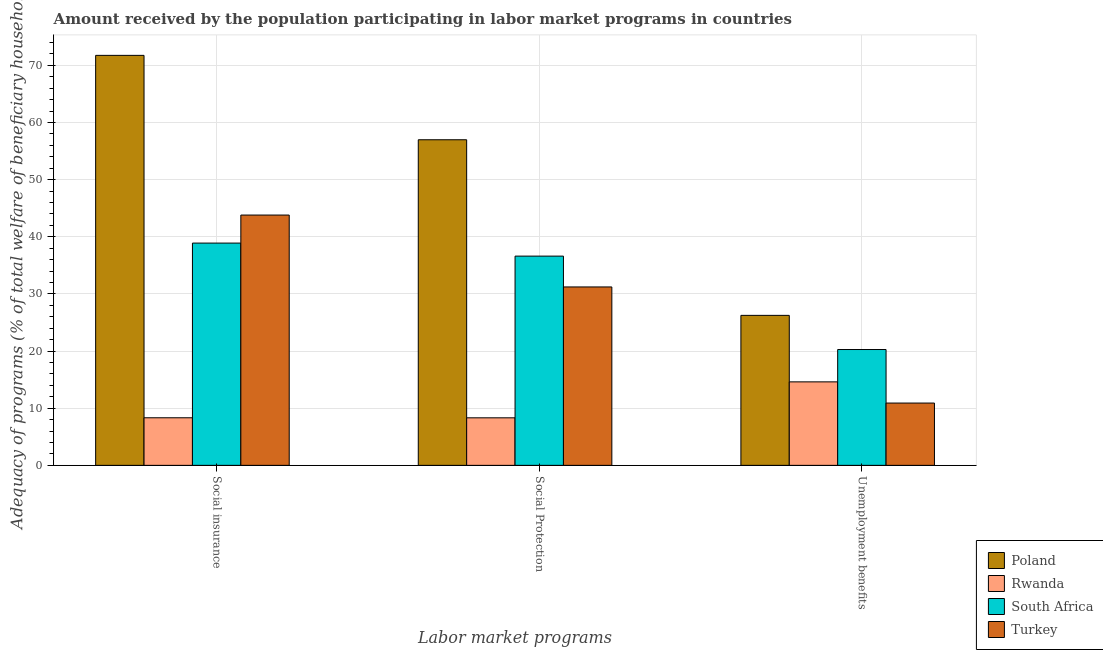How many groups of bars are there?
Your answer should be compact. 3. Are the number of bars per tick equal to the number of legend labels?
Give a very brief answer. Yes. Are the number of bars on each tick of the X-axis equal?
Offer a terse response. Yes. How many bars are there on the 2nd tick from the left?
Give a very brief answer. 4. How many bars are there on the 2nd tick from the right?
Your response must be concise. 4. What is the label of the 3rd group of bars from the left?
Make the answer very short. Unemployment benefits. What is the amount received by the population participating in social protection programs in Turkey?
Provide a succinct answer. 31.22. Across all countries, what is the maximum amount received by the population participating in unemployment benefits programs?
Provide a succinct answer. 26.25. Across all countries, what is the minimum amount received by the population participating in unemployment benefits programs?
Your answer should be compact. 10.9. What is the total amount received by the population participating in social protection programs in the graph?
Keep it short and to the point. 133.15. What is the difference between the amount received by the population participating in social protection programs in Turkey and that in Poland?
Provide a succinct answer. -25.76. What is the difference between the amount received by the population participating in unemployment benefits programs in Turkey and the amount received by the population participating in social protection programs in Poland?
Provide a succinct answer. -46.08. What is the average amount received by the population participating in unemployment benefits programs per country?
Your answer should be very brief. 18.01. What is the difference between the amount received by the population participating in social protection programs and amount received by the population participating in unemployment benefits programs in South Africa?
Offer a very short reply. 16.35. What is the ratio of the amount received by the population participating in social insurance programs in South Africa to that in Poland?
Give a very brief answer. 0.54. Is the amount received by the population participating in unemployment benefits programs in Rwanda less than that in Poland?
Provide a succinct answer. Yes. What is the difference between the highest and the second highest amount received by the population participating in unemployment benefits programs?
Your response must be concise. 5.98. What is the difference between the highest and the lowest amount received by the population participating in social protection programs?
Offer a very short reply. 48.67. Is the sum of the amount received by the population participating in social protection programs in Rwanda and Poland greater than the maximum amount received by the population participating in unemployment benefits programs across all countries?
Ensure brevity in your answer.  Yes. What does the 2nd bar from the left in Social Protection represents?
Offer a terse response. Rwanda. Are all the bars in the graph horizontal?
Provide a succinct answer. No. Does the graph contain any zero values?
Your answer should be compact. No. Where does the legend appear in the graph?
Offer a very short reply. Bottom right. What is the title of the graph?
Provide a succinct answer. Amount received by the population participating in labor market programs in countries. Does "Uganda" appear as one of the legend labels in the graph?
Give a very brief answer. No. What is the label or title of the X-axis?
Make the answer very short. Labor market programs. What is the label or title of the Y-axis?
Offer a terse response. Adequacy of programs (% of total welfare of beneficiary households). What is the Adequacy of programs (% of total welfare of beneficiary households) of Poland in Social insurance?
Give a very brief answer. 71.75. What is the Adequacy of programs (% of total welfare of beneficiary households) in Rwanda in Social insurance?
Your answer should be very brief. 8.33. What is the Adequacy of programs (% of total welfare of beneficiary households) in South Africa in Social insurance?
Make the answer very short. 38.9. What is the Adequacy of programs (% of total welfare of beneficiary households) in Turkey in Social insurance?
Give a very brief answer. 43.81. What is the Adequacy of programs (% of total welfare of beneficiary households) in Poland in Social Protection?
Your response must be concise. 56.99. What is the Adequacy of programs (% of total welfare of beneficiary households) in Rwanda in Social Protection?
Make the answer very short. 8.32. What is the Adequacy of programs (% of total welfare of beneficiary households) in South Africa in Social Protection?
Offer a terse response. 36.62. What is the Adequacy of programs (% of total welfare of beneficiary households) of Turkey in Social Protection?
Offer a very short reply. 31.22. What is the Adequacy of programs (% of total welfare of beneficiary households) in Poland in Unemployment benefits?
Provide a short and direct response. 26.25. What is the Adequacy of programs (% of total welfare of beneficiary households) in Rwanda in Unemployment benefits?
Provide a succinct answer. 14.61. What is the Adequacy of programs (% of total welfare of beneficiary households) of South Africa in Unemployment benefits?
Your response must be concise. 20.27. What is the Adequacy of programs (% of total welfare of beneficiary households) of Turkey in Unemployment benefits?
Make the answer very short. 10.9. Across all Labor market programs, what is the maximum Adequacy of programs (% of total welfare of beneficiary households) of Poland?
Offer a very short reply. 71.75. Across all Labor market programs, what is the maximum Adequacy of programs (% of total welfare of beneficiary households) in Rwanda?
Keep it short and to the point. 14.61. Across all Labor market programs, what is the maximum Adequacy of programs (% of total welfare of beneficiary households) in South Africa?
Provide a succinct answer. 38.9. Across all Labor market programs, what is the maximum Adequacy of programs (% of total welfare of beneficiary households) in Turkey?
Provide a succinct answer. 43.81. Across all Labor market programs, what is the minimum Adequacy of programs (% of total welfare of beneficiary households) in Poland?
Ensure brevity in your answer.  26.25. Across all Labor market programs, what is the minimum Adequacy of programs (% of total welfare of beneficiary households) in Rwanda?
Keep it short and to the point. 8.32. Across all Labor market programs, what is the minimum Adequacy of programs (% of total welfare of beneficiary households) of South Africa?
Make the answer very short. 20.27. Across all Labor market programs, what is the minimum Adequacy of programs (% of total welfare of beneficiary households) of Turkey?
Keep it short and to the point. 10.9. What is the total Adequacy of programs (% of total welfare of beneficiary households) in Poland in the graph?
Offer a terse response. 154.99. What is the total Adequacy of programs (% of total welfare of beneficiary households) of Rwanda in the graph?
Keep it short and to the point. 31.26. What is the total Adequacy of programs (% of total welfare of beneficiary households) of South Africa in the graph?
Give a very brief answer. 95.79. What is the total Adequacy of programs (% of total welfare of beneficiary households) of Turkey in the graph?
Offer a very short reply. 85.93. What is the difference between the Adequacy of programs (% of total welfare of beneficiary households) in Poland in Social insurance and that in Social Protection?
Provide a short and direct response. 14.77. What is the difference between the Adequacy of programs (% of total welfare of beneficiary households) of Rwanda in Social insurance and that in Social Protection?
Offer a terse response. 0.01. What is the difference between the Adequacy of programs (% of total welfare of beneficiary households) of South Africa in Social insurance and that in Social Protection?
Provide a short and direct response. 2.28. What is the difference between the Adequacy of programs (% of total welfare of beneficiary households) of Turkey in Social insurance and that in Social Protection?
Keep it short and to the point. 12.58. What is the difference between the Adequacy of programs (% of total welfare of beneficiary households) in Poland in Social insurance and that in Unemployment benefits?
Ensure brevity in your answer.  45.5. What is the difference between the Adequacy of programs (% of total welfare of beneficiary households) of Rwanda in Social insurance and that in Unemployment benefits?
Offer a very short reply. -6.28. What is the difference between the Adequacy of programs (% of total welfare of beneficiary households) in South Africa in Social insurance and that in Unemployment benefits?
Give a very brief answer. 18.63. What is the difference between the Adequacy of programs (% of total welfare of beneficiary households) of Turkey in Social insurance and that in Unemployment benefits?
Give a very brief answer. 32.9. What is the difference between the Adequacy of programs (% of total welfare of beneficiary households) of Poland in Social Protection and that in Unemployment benefits?
Provide a succinct answer. 30.74. What is the difference between the Adequacy of programs (% of total welfare of beneficiary households) of Rwanda in Social Protection and that in Unemployment benefits?
Offer a terse response. -6.29. What is the difference between the Adequacy of programs (% of total welfare of beneficiary households) in South Africa in Social Protection and that in Unemployment benefits?
Offer a terse response. 16.35. What is the difference between the Adequacy of programs (% of total welfare of beneficiary households) in Turkey in Social Protection and that in Unemployment benefits?
Your answer should be very brief. 20.32. What is the difference between the Adequacy of programs (% of total welfare of beneficiary households) of Poland in Social insurance and the Adequacy of programs (% of total welfare of beneficiary households) of Rwanda in Social Protection?
Your answer should be very brief. 63.43. What is the difference between the Adequacy of programs (% of total welfare of beneficiary households) in Poland in Social insurance and the Adequacy of programs (% of total welfare of beneficiary households) in South Africa in Social Protection?
Your answer should be very brief. 35.13. What is the difference between the Adequacy of programs (% of total welfare of beneficiary households) in Poland in Social insurance and the Adequacy of programs (% of total welfare of beneficiary households) in Turkey in Social Protection?
Provide a short and direct response. 40.53. What is the difference between the Adequacy of programs (% of total welfare of beneficiary households) of Rwanda in Social insurance and the Adequacy of programs (% of total welfare of beneficiary households) of South Africa in Social Protection?
Provide a short and direct response. -28.29. What is the difference between the Adequacy of programs (% of total welfare of beneficiary households) in Rwanda in Social insurance and the Adequacy of programs (% of total welfare of beneficiary households) in Turkey in Social Protection?
Your answer should be compact. -22.9. What is the difference between the Adequacy of programs (% of total welfare of beneficiary households) of South Africa in Social insurance and the Adequacy of programs (% of total welfare of beneficiary households) of Turkey in Social Protection?
Make the answer very short. 7.68. What is the difference between the Adequacy of programs (% of total welfare of beneficiary households) in Poland in Social insurance and the Adequacy of programs (% of total welfare of beneficiary households) in Rwanda in Unemployment benefits?
Your answer should be very brief. 57.14. What is the difference between the Adequacy of programs (% of total welfare of beneficiary households) in Poland in Social insurance and the Adequacy of programs (% of total welfare of beneficiary households) in South Africa in Unemployment benefits?
Keep it short and to the point. 51.48. What is the difference between the Adequacy of programs (% of total welfare of beneficiary households) in Poland in Social insurance and the Adequacy of programs (% of total welfare of beneficiary households) in Turkey in Unemployment benefits?
Provide a succinct answer. 60.85. What is the difference between the Adequacy of programs (% of total welfare of beneficiary households) in Rwanda in Social insurance and the Adequacy of programs (% of total welfare of beneficiary households) in South Africa in Unemployment benefits?
Make the answer very short. -11.94. What is the difference between the Adequacy of programs (% of total welfare of beneficiary households) of Rwanda in Social insurance and the Adequacy of programs (% of total welfare of beneficiary households) of Turkey in Unemployment benefits?
Ensure brevity in your answer.  -2.58. What is the difference between the Adequacy of programs (% of total welfare of beneficiary households) in South Africa in Social insurance and the Adequacy of programs (% of total welfare of beneficiary households) in Turkey in Unemployment benefits?
Your answer should be compact. 28. What is the difference between the Adequacy of programs (% of total welfare of beneficiary households) in Poland in Social Protection and the Adequacy of programs (% of total welfare of beneficiary households) in Rwanda in Unemployment benefits?
Offer a very short reply. 42.38. What is the difference between the Adequacy of programs (% of total welfare of beneficiary households) in Poland in Social Protection and the Adequacy of programs (% of total welfare of beneficiary households) in South Africa in Unemployment benefits?
Your response must be concise. 36.71. What is the difference between the Adequacy of programs (% of total welfare of beneficiary households) of Poland in Social Protection and the Adequacy of programs (% of total welfare of beneficiary households) of Turkey in Unemployment benefits?
Ensure brevity in your answer.  46.08. What is the difference between the Adequacy of programs (% of total welfare of beneficiary households) in Rwanda in Social Protection and the Adequacy of programs (% of total welfare of beneficiary households) in South Africa in Unemployment benefits?
Make the answer very short. -11.95. What is the difference between the Adequacy of programs (% of total welfare of beneficiary households) of Rwanda in Social Protection and the Adequacy of programs (% of total welfare of beneficiary households) of Turkey in Unemployment benefits?
Provide a short and direct response. -2.58. What is the difference between the Adequacy of programs (% of total welfare of beneficiary households) in South Africa in Social Protection and the Adequacy of programs (% of total welfare of beneficiary households) in Turkey in Unemployment benefits?
Make the answer very short. 25.72. What is the average Adequacy of programs (% of total welfare of beneficiary households) of Poland per Labor market programs?
Offer a terse response. 51.66. What is the average Adequacy of programs (% of total welfare of beneficiary households) in Rwanda per Labor market programs?
Keep it short and to the point. 10.42. What is the average Adequacy of programs (% of total welfare of beneficiary households) of South Africa per Labor market programs?
Make the answer very short. 31.93. What is the average Adequacy of programs (% of total welfare of beneficiary households) in Turkey per Labor market programs?
Ensure brevity in your answer.  28.64. What is the difference between the Adequacy of programs (% of total welfare of beneficiary households) in Poland and Adequacy of programs (% of total welfare of beneficiary households) in Rwanda in Social insurance?
Make the answer very short. 63.43. What is the difference between the Adequacy of programs (% of total welfare of beneficiary households) of Poland and Adequacy of programs (% of total welfare of beneficiary households) of South Africa in Social insurance?
Your response must be concise. 32.85. What is the difference between the Adequacy of programs (% of total welfare of beneficiary households) of Poland and Adequacy of programs (% of total welfare of beneficiary households) of Turkey in Social insurance?
Offer a terse response. 27.95. What is the difference between the Adequacy of programs (% of total welfare of beneficiary households) of Rwanda and Adequacy of programs (% of total welfare of beneficiary households) of South Africa in Social insurance?
Ensure brevity in your answer.  -30.57. What is the difference between the Adequacy of programs (% of total welfare of beneficiary households) in Rwanda and Adequacy of programs (% of total welfare of beneficiary households) in Turkey in Social insurance?
Offer a very short reply. -35.48. What is the difference between the Adequacy of programs (% of total welfare of beneficiary households) of South Africa and Adequacy of programs (% of total welfare of beneficiary households) of Turkey in Social insurance?
Provide a succinct answer. -4.91. What is the difference between the Adequacy of programs (% of total welfare of beneficiary households) in Poland and Adequacy of programs (% of total welfare of beneficiary households) in Rwanda in Social Protection?
Keep it short and to the point. 48.67. What is the difference between the Adequacy of programs (% of total welfare of beneficiary households) of Poland and Adequacy of programs (% of total welfare of beneficiary households) of South Africa in Social Protection?
Provide a succinct answer. 20.36. What is the difference between the Adequacy of programs (% of total welfare of beneficiary households) in Poland and Adequacy of programs (% of total welfare of beneficiary households) in Turkey in Social Protection?
Ensure brevity in your answer.  25.76. What is the difference between the Adequacy of programs (% of total welfare of beneficiary households) of Rwanda and Adequacy of programs (% of total welfare of beneficiary households) of South Africa in Social Protection?
Your response must be concise. -28.3. What is the difference between the Adequacy of programs (% of total welfare of beneficiary households) of Rwanda and Adequacy of programs (% of total welfare of beneficiary households) of Turkey in Social Protection?
Offer a very short reply. -22.9. What is the difference between the Adequacy of programs (% of total welfare of beneficiary households) in South Africa and Adequacy of programs (% of total welfare of beneficiary households) in Turkey in Social Protection?
Offer a terse response. 5.4. What is the difference between the Adequacy of programs (% of total welfare of beneficiary households) of Poland and Adequacy of programs (% of total welfare of beneficiary households) of Rwanda in Unemployment benefits?
Give a very brief answer. 11.64. What is the difference between the Adequacy of programs (% of total welfare of beneficiary households) in Poland and Adequacy of programs (% of total welfare of beneficiary households) in South Africa in Unemployment benefits?
Keep it short and to the point. 5.98. What is the difference between the Adequacy of programs (% of total welfare of beneficiary households) in Poland and Adequacy of programs (% of total welfare of beneficiary households) in Turkey in Unemployment benefits?
Provide a short and direct response. 15.35. What is the difference between the Adequacy of programs (% of total welfare of beneficiary households) of Rwanda and Adequacy of programs (% of total welfare of beneficiary households) of South Africa in Unemployment benefits?
Provide a short and direct response. -5.66. What is the difference between the Adequacy of programs (% of total welfare of beneficiary households) in Rwanda and Adequacy of programs (% of total welfare of beneficiary households) in Turkey in Unemployment benefits?
Your response must be concise. 3.71. What is the difference between the Adequacy of programs (% of total welfare of beneficiary households) of South Africa and Adequacy of programs (% of total welfare of beneficiary households) of Turkey in Unemployment benefits?
Offer a terse response. 9.37. What is the ratio of the Adequacy of programs (% of total welfare of beneficiary households) of Poland in Social insurance to that in Social Protection?
Keep it short and to the point. 1.26. What is the ratio of the Adequacy of programs (% of total welfare of beneficiary households) of Rwanda in Social insurance to that in Social Protection?
Provide a succinct answer. 1. What is the ratio of the Adequacy of programs (% of total welfare of beneficiary households) of South Africa in Social insurance to that in Social Protection?
Provide a short and direct response. 1.06. What is the ratio of the Adequacy of programs (% of total welfare of beneficiary households) of Turkey in Social insurance to that in Social Protection?
Offer a very short reply. 1.4. What is the ratio of the Adequacy of programs (% of total welfare of beneficiary households) in Poland in Social insurance to that in Unemployment benefits?
Your answer should be compact. 2.73. What is the ratio of the Adequacy of programs (% of total welfare of beneficiary households) of Rwanda in Social insurance to that in Unemployment benefits?
Offer a very short reply. 0.57. What is the ratio of the Adequacy of programs (% of total welfare of beneficiary households) of South Africa in Social insurance to that in Unemployment benefits?
Provide a succinct answer. 1.92. What is the ratio of the Adequacy of programs (% of total welfare of beneficiary households) in Turkey in Social insurance to that in Unemployment benefits?
Your answer should be compact. 4.02. What is the ratio of the Adequacy of programs (% of total welfare of beneficiary households) in Poland in Social Protection to that in Unemployment benefits?
Give a very brief answer. 2.17. What is the ratio of the Adequacy of programs (% of total welfare of beneficiary households) in Rwanda in Social Protection to that in Unemployment benefits?
Give a very brief answer. 0.57. What is the ratio of the Adequacy of programs (% of total welfare of beneficiary households) of South Africa in Social Protection to that in Unemployment benefits?
Offer a terse response. 1.81. What is the ratio of the Adequacy of programs (% of total welfare of beneficiary households) of Turkey in Social Protection to that in Unemployment benefits?
Provide a succinct answer. 2.86. What is the difference between the highest and the second highest Adequacy of programs (% of total welfare of beneficiary households) in Poland?
Your answer should be very brief. 14.77. What is the difference between the highest and the second highest Adequacy of programs (% of total welfare of beneficiary households) of Rwanda?
Ensure brevity in your answer.  6.28. What is the difference between the highest and the second highest Adequacy of programs (% of total welfare of beneficiary households) in South Africa?
Provide a short and direct response. 2.28. What is the difference between the highest and the second highest Adequacy of programs (% of total welfare of beneficiary households) in Turkey?
Provide a short and direct response. 12.58. What is the difference between the highest and the lowest Adequacy of programs (% of total welfare of beneficiary households) of Poland?
Provide a short and direct response. 45.5. What is the difference between the highest and the lowest Adequacy of programs (% of total welfare of beneficiary households) in Rwanda?
Provide a succinct answer. 6.29. What is the difference between the highest and the lowest Adequacy of programs (% of total welfare of beneficiary households) in South Africa?
Your answer should be compact. 18.63. What is the difference between the highest and the lowest Adequacy of programs (% of total welfare of beneficiary households) of Turkey?
Your answer should be very brief. 32.9. 